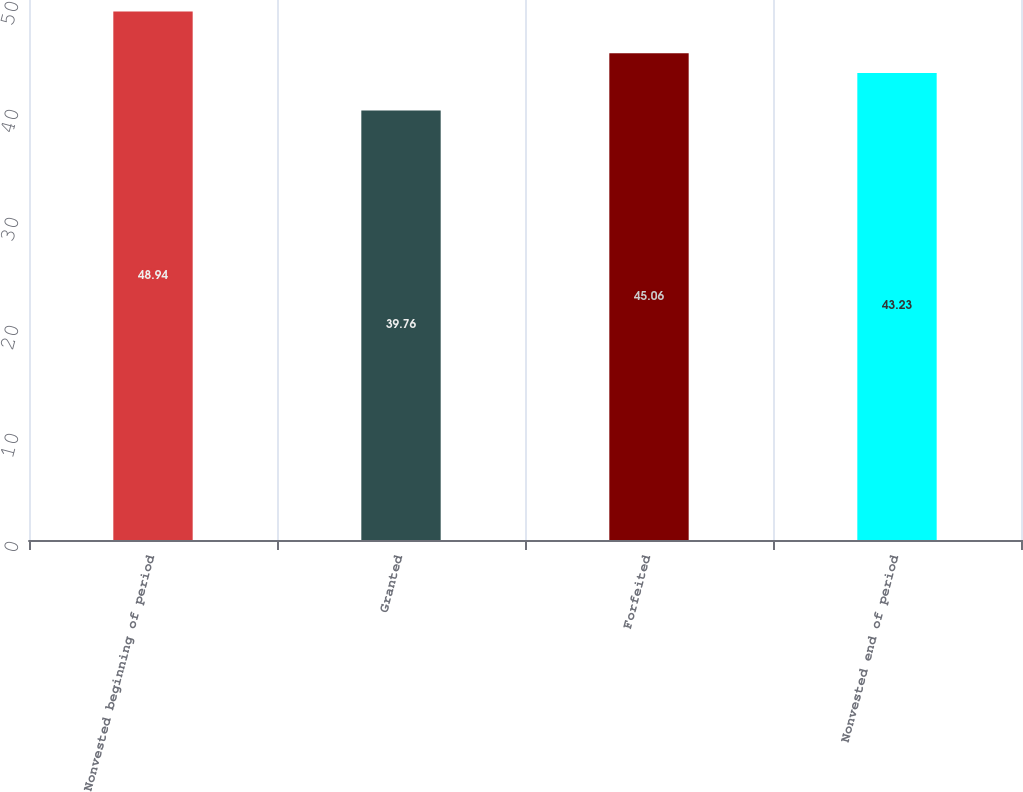Convert chart to OTSL. <chart><loc_0><loc_0><loc_500><loc_500><bar_chart><fcel>Nonvested beginning of period<fcel>Granted<fcel>Forfeited<fcel>Nonvested end of period<nl><fcel>48.94<fcel>39.76<fcel>45.06<fcel>43.23<nl></chart> 